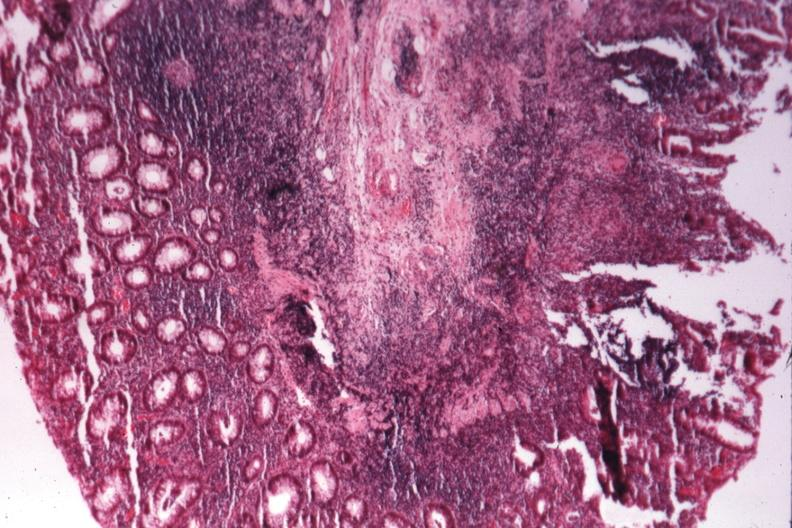what does this image show?
Answer the question using a single word or phrase. Source of granulomatous colitis 